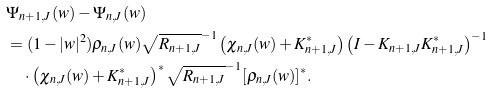Convert formula to latex. <formula><loc_0><loc_0><loc_500><loc_500>& \Psi _ { n + 1 , J } ( w ) - \Psi _ { n , J } ( w ) \\ & = ( 1 - | w | ^ { 2 } ) \rho _ { n , J } ( w ) \sqrt { R _ { n + 1 , J } } ^ { - 1 } \left ( \chi _ { n , J } ( w ) + K _ { n + 1 , J } ^ { * } \right ) \left ( I - K _ { n + 1 , J } K _ { n + 1 , J } ^ { * } \right ) ^ { - 1 } \\ & \quad \cdot \left ( \chi _ { n , J } ( w ) + K _ { n + 1 , J } ^ { * } \right ) ^ { * } \sqrt { R _ { n + 1 , J } } ^ { - 1 } [ \rho _ { n , J } ( w ) ] ^ { * } .</formula> 